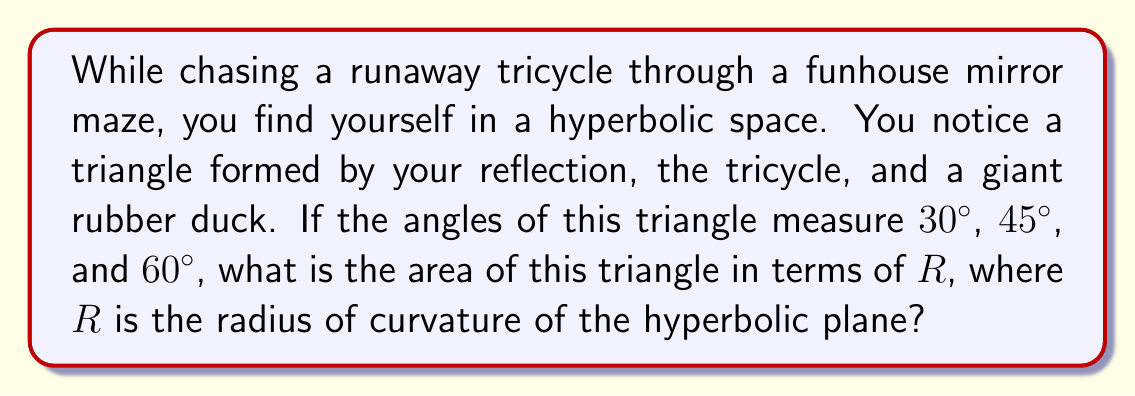Give your solution to this math problem. Let's approach this step-by-step:

1) In hyperbolic geometry, the sum of angles in a triangle is less than $180°$. The defect (difference from $180°$) is related to the area of the triangle.

2) Let's calculate the sum of the given angles:
   $30° + 45° + 60° = 135°$

3) The defect is:
   $180° - 135° = 45° = \frac{\pi}{4}$ radians

4) In hyperbolic geometry, the area of a triangle is given by the formula:
   $A = R^2(\pi - (\alpha + \beta + \gamma))$
   where $R$ is the radius of curvature, and $\alpha$, $\beta$, and $\gamma$ are the angles in radians.

5) We can rewrite this as:
   $A = R^2(\text{defect})$

6) Substituting our defect:
   $A = R^2 \cdot \frac{\pi}{4}$

Therefore, the area of the triangle is $\frac{\pi R^2}{4}$.
Answer: $\frac{\pi R^2}{4}$ 